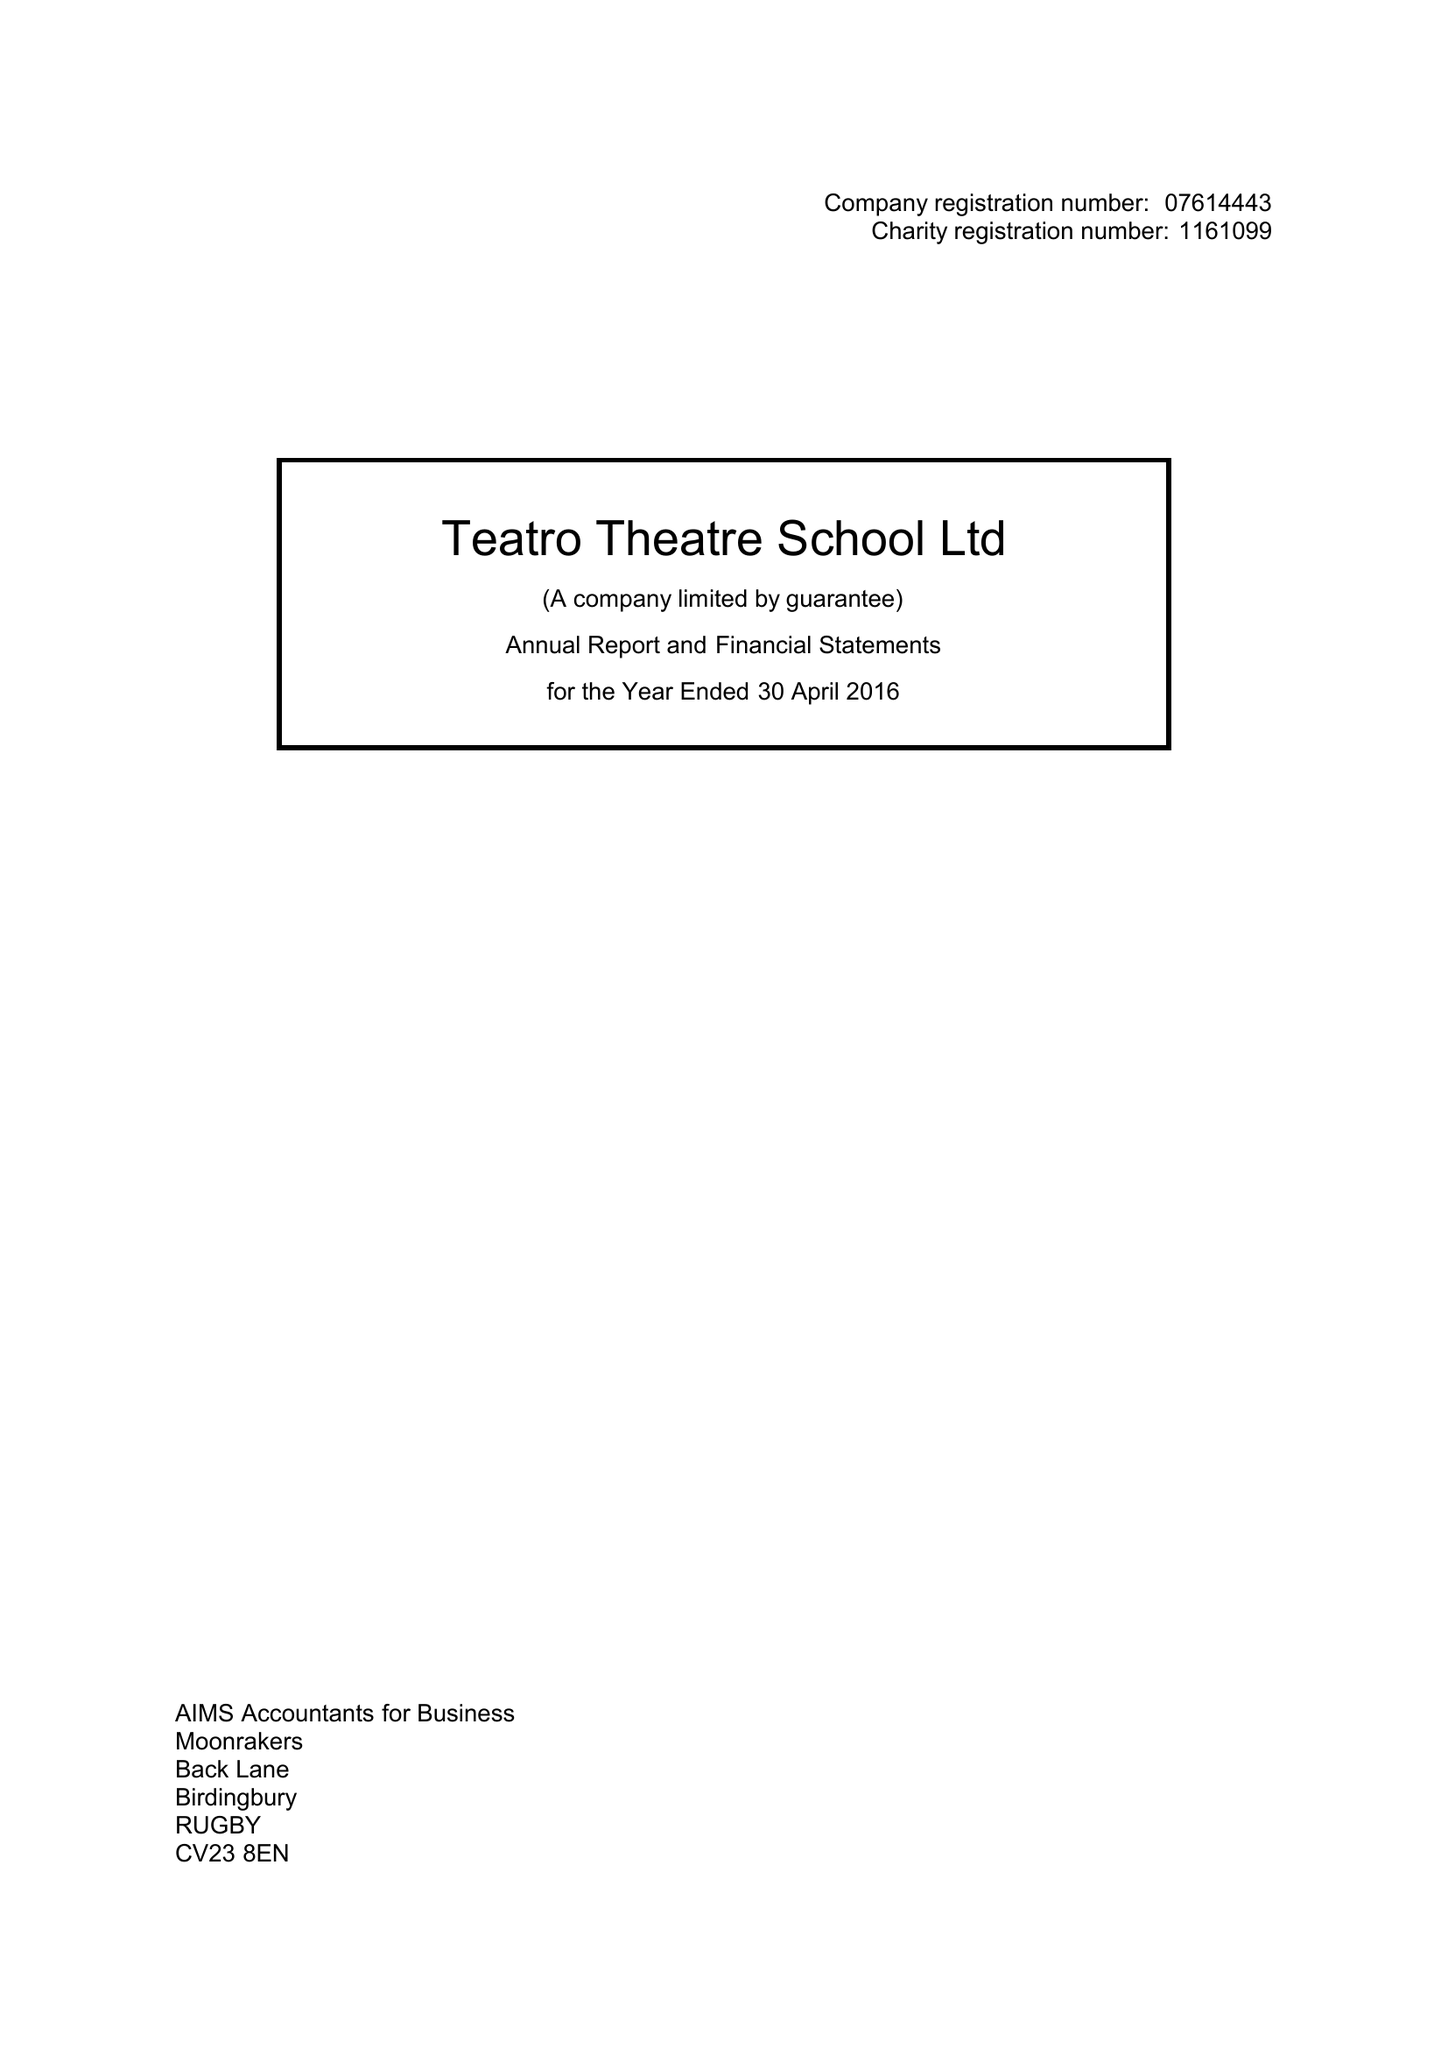What is the value for the address__post_town?
Answer the question using a single word or phrase. LEAMINGTON SPA 